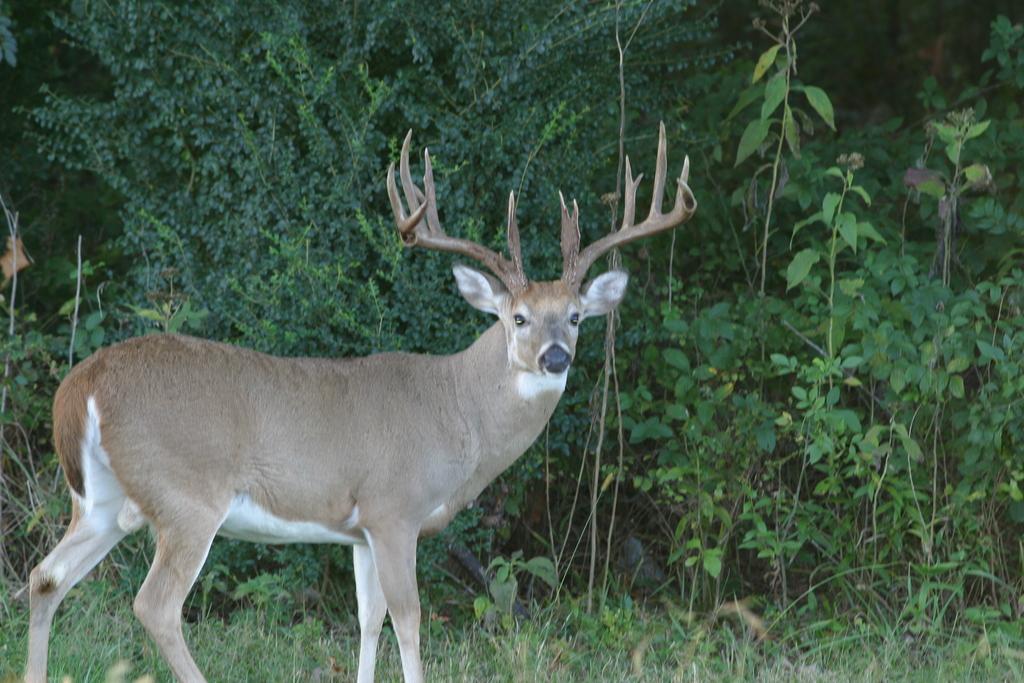Could you give a brief overview of what you see in this image? In this image, we can see a deer is standing. At the bottom, there is a grass. Background we can see few plants and trees. 